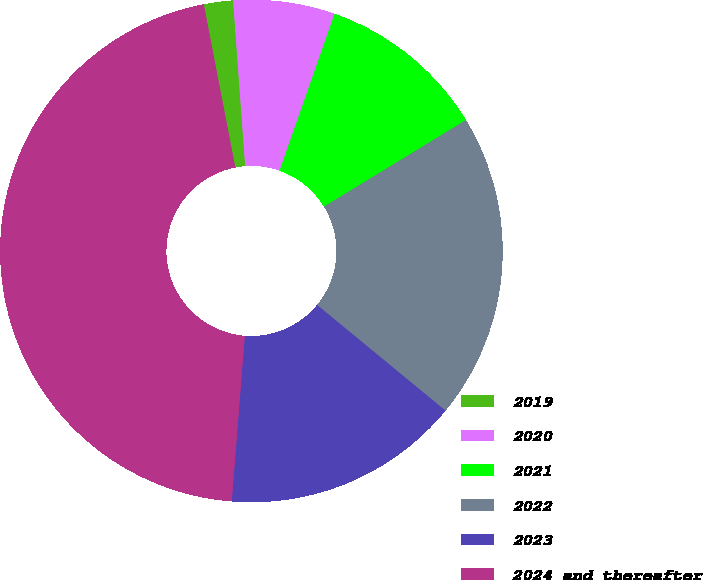Convert chart to OTSL. <chart><loc_0><loc_0><loc_500><loc_500><pie_chart><fcel>2019<fcel>2020<fcel>2021<fcel>2022<fcel>2023<fcel>2024 and thereafter<nl><fcel>1.88%<fcel>6.53%<fcel>10.91%<fcel>19.68%<fcel>15.29%<fcel>45.71%<nl></chart> 